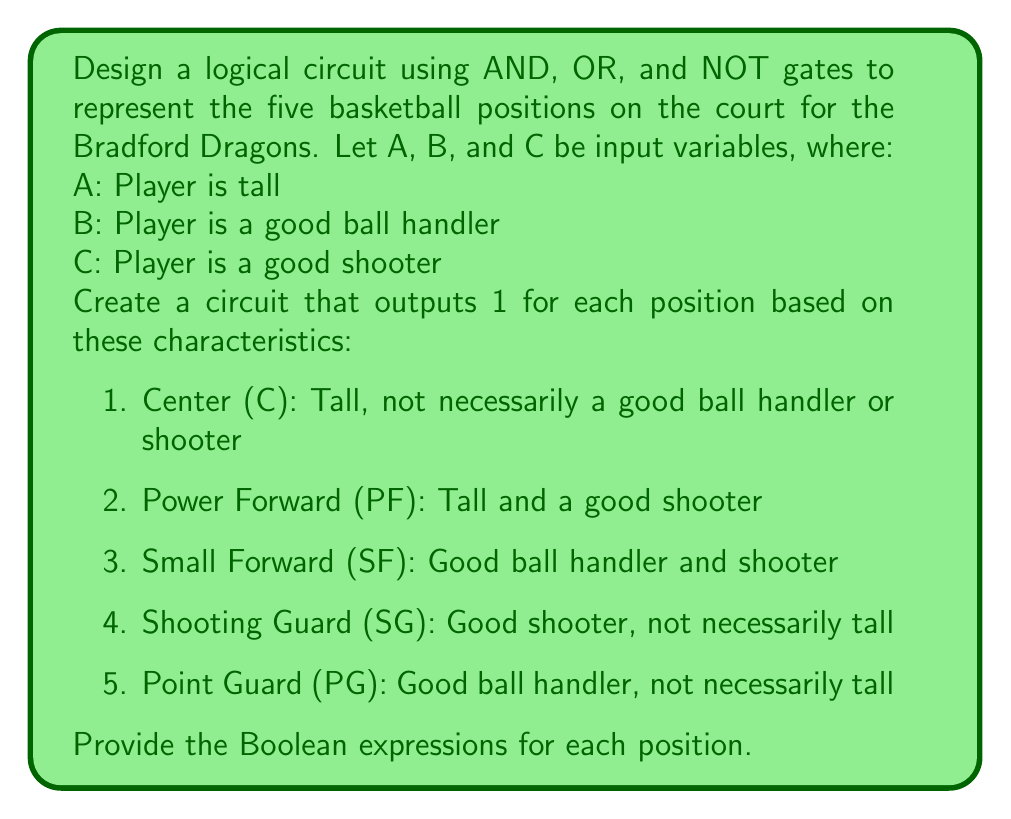Teach me how to tackle this problem. Let's break this down step-by-step for each position:

1. Center (C):
   - Needs to be tall (A), other characteristics don't matter
   - Boolean expression: $C = A$

2. Power Forward (PF):
   - Needs to be tall (A) AND a good shooter (C)
   - Boolean expression: $PF = A \cdot C$

3. Small Forward (SF):
   - Needs to be a good ball handler (B) AND a good shooter (C)
   - Boolean expression: $SF = B \cdot C$

4. Shooting Guard (SG):
   - Needs to be a good shooter (C), height doesn't matter
   - Boolean expression: $SG = C$

5. Point Guard (PG):
   - Needs to be a good ball handler (B), height doesn't matter
   - Boolean expression: $PG = B$

Now, let's design the circuit:

[asy]
import geometry;

// Define points
pair A = (0,0), B = (0,-50), C = (0,-100);
pair AND1 = (100,-25), AND2 = (100,-75);
pair OR = (200,-50);

// Draw input lines
draw(A--AND1, arrow=Arrow(TeXHead));
draw(B--AND1, arrow=Arrow(TeXHead));
draw(B--AND2, arrow=Arrow(TeXHead));
draw(C--AND1, arrow=Arrow(TeXHead));
draw(C--AND2, arrow=Arrow(TeXHead));

// Draw gates
draw(circle((100,-25),15));
draw(circle((100,-75),15));
draw(circle((200,-50),15));

// Draw output lines
draw(AND1--OR, arrow=Arrow(TeXHead));
draw(AND2--OR, arrow=Arrow(TeXHead));

// Labels
label("A", A, W);
label("B", B, W);
label("C", C, W);
label("AND", (85,-25), W);
label("AND", (85,-75), W);
label("OR", (185,-50), W);
label("PF", (215,-50), E);

// Output lines for other positions
draw(A--(250,0), arrow=Arrow(TeXHead));
label("C", (265,0), E);
draw(B--(250,-100), arrow=Arrow(TeXHead));
label("PG", (265,-100), E);
draw(C--(250,-50), arrow=Arrow(TeXHead));
label("SG", (265,-50), E);
[/asy]

This circuit represents the Boolean expressions for each position. The AND gates are used for positions requiring multiple characteristics, while the OR gate is used to combine the outputs for PF and SF, which both require two characteristics.
Answer: $C = A$, $PF = A \cdot C$, $SF = B \cdot C$, $SG = C$, $PG = B$ 